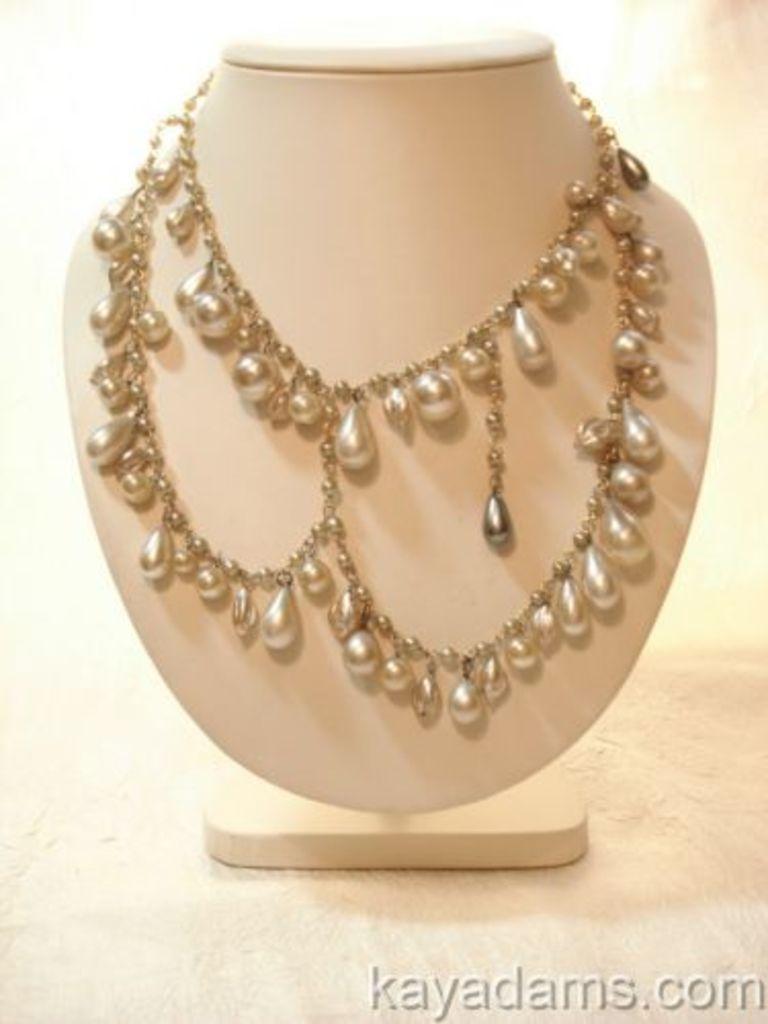Could you give a brief overview of what you see in this image? In this image we can see the jewelry on the plain surface. At the bottom we can see the text. 